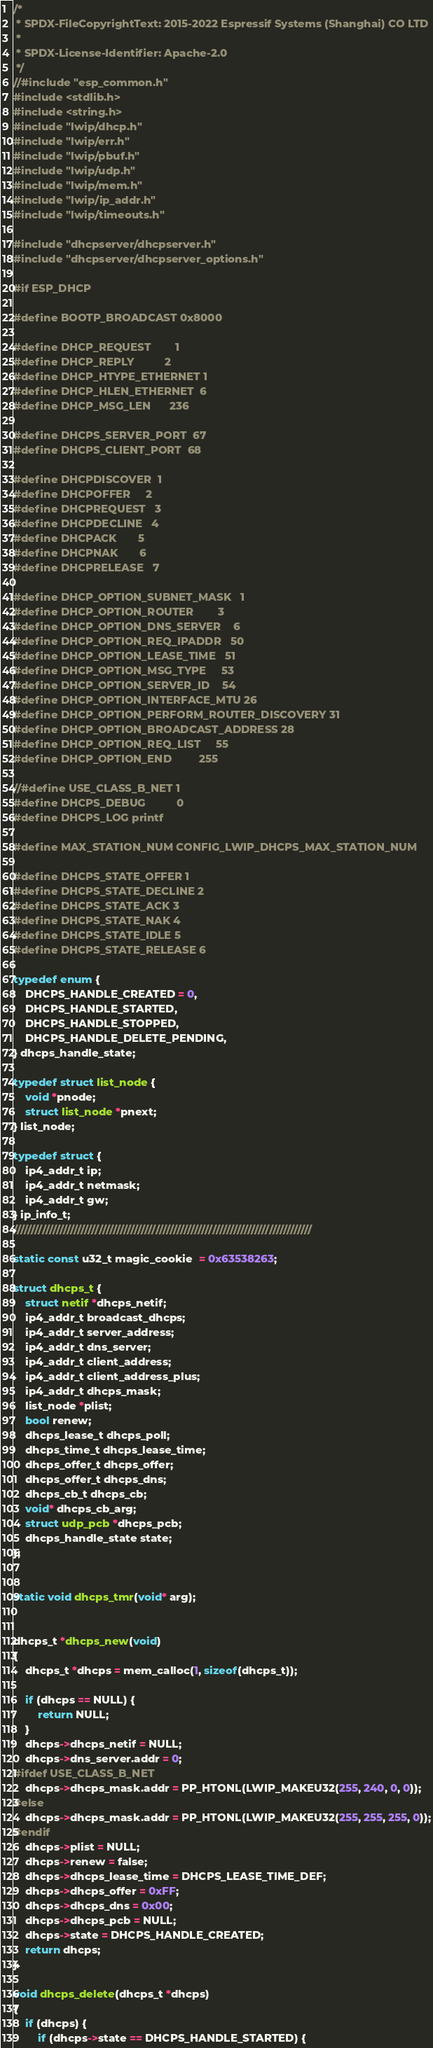<code> <loc_0><loc_0><loc_500><loc_500><_C_>/*
 * SPDX-FileCopyrightText: 2015-2022 Espressif Systems (Shanghai) CO LTD
 *
 * SPDX-License-Identifier: Apache-2.0
 */
//#include "esp_common.h"
#include <stdlib.h>
#include <string.h>
#include "lwip/dhcp.h"
#include "lwip/err.h"
#include "lwip/pbuf.h"
#include "lwip/udp.h"
#include "lwip/mem.h"
#include "lwip/ip_addr.h"
#include "lwip/timeouts.h"

#include "dhcpserver/dhcpserver.h"
#include "dhcpserver/dhcpserver_options.h"

#if ESP_DHCP

#define BOOTP_BROADCAST 0x8000

#define DHCP_REQUEST        1
#define DHCP_REPLY          2
#define DHCP_HTYPE_ETHERNET 1
#define DHCP_HLEN_ETHERNET  6
#define DHCP_MSG_LEN      236

#define DHCPS_SERVER_PORT  67
#define DHCPS_CLIENT_PORT  68

#define DHCPDISCOVER  1
#define DHCPOFFER     2
#define DHCPREQUEST   3
#define DHCPDECLINE   4
#define DHCPACK       5
#define DHCPNAK       6
#define DHCPRELEASE   7

#define DHCP_OPTION_SUBNET_MASK   1
#define DHCP_OPTION_ROUTER        3
#define DHCP_OPTION_DNS_SERVER    6
#define DHCP_OPTION_REQ_IPADDR   50
#define DHCP_OPTION_LEASE_TIME   51
#define DHCP_OPTION_MSG_TYPE     53
#define DHCP_OPTION_SERVER_ID    54
#define DHCP_OPTION_INTERFACE_MTU 26
#define DHCP_OPTION_PERFORM_ROUTER_DISCOVERY 31
#define DHCP_OPTION_BROADCAST_ADDRESS 28
#define DHCP_OPTION_REQ_LIST     55
#define DHCP_OPTION_END         255

//#define USE_CLASS_B_NET 1
#define DHCPS_DEBUG          0
#define DHCPS_LOG printf

#define MAX_STATION_NUM CONFIG_LWIP_DHCPS_MAX_STATION_NUM

#define DHCPS_STATE_OFFER 1
#define DHCPS_STATE_DECLINE 2
#define DHCPS_STATE_ACK 3
#define DHCPS_STATE_NAK 4
#define DHCPS_STATE_IDLE 5
#define DHCPS_STATE_RELEASE 6

typedef enum {
    DHCPS_HANDLE_CREATED = 0,
    DHCPS_HANDLE_STARTED,
    DHCPS_HANDLE_STOPPED,
    DHCPS_HANDLE_DELETE_PENDING,
} dhcps_handle_state;

typedef struct list_node {
	void *pnode;
	struct list_node *pnext;
} list_node;

typedef struct {
    ip4_addr_t ip;
    ip4_addr_t netmask;
    ip4_addr_t gw;
} ip_info_t;
////////////////////////////////////////////////////////////////////////////////////

static const u32_t magic_cookie  = 0x63538263;

struct dhcps_t {
    struct netif *dhcps_netif;
    ip4_addr_t broadcast_dhcps;
    ip4_addr_t server_address;
    ip4_addr_t dns_server;
    ip4_addr_t client_address;
    ip4_addr_t client_address_plus;
    ip4_addr_t dhcps_mask;
    list_node *plist;
    bool renew;
    dhcps_lease_t dhcps_poll;
    dhcps_time_t dhcps_lease_time;
    dhcps_offer_t dhcps_offer;
    dhcps_offer_t dhcps_dns;
    dhcps_cb_t dhcps_cb;
    void* dhcps_cb_arg;
    struct udp_pcb *dhcps_pcb;
    dhcps_handle_state state;
};


static void dhcps_tmr(void* arg);


dhcps_t *dhcps_new(void)
{
    dhcps_t *dhcps = mem_calloc(1, sizeof(dhcps_t));

    if (dhcps == NULL) {
        return NULL;
    }
    dhcps->dhcps_netif = NULL;
    dhcps->dns_server.addr = 0;
#ifdef USE_CLASS_B_NET
    dhcps->dhcps_mask.addr = PP_HTONL(LWIP_MAKEU32(255, 240, 0, 0));
#else
    dhcps->dhcps_mask.addr = PP_HTONL(LWIP_MAKEU32(255, 255, 255, 0));
#endif
    dhcps->plist = NULL;
    dhcps->renew = false;
    dhcps->dhcps_lease_time = DHCPS_LEASE_TIME_DEF;
    dhcps->dhcps_offer = 0xFF;
    dhcps->dhcps_dns = 0x00;
    dhcps->dhcps_pcb = NULL;
    dhcps->state = DHCPS_HANDLE_CREATED;
    return dhcps;
}

void dhcps_delete(dhcps_t *dhcps)
{
    if (dhcps) {
        if (dhcps->state == DHCPS_HANDLE_STARTED) {</code> 